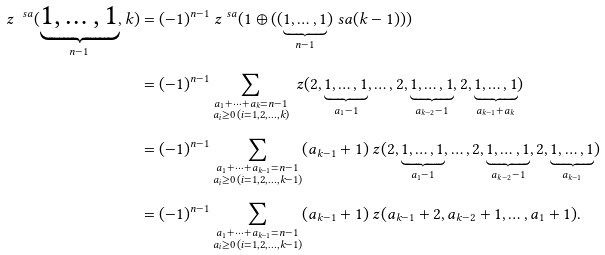<formula> <loc_0><loc_0><loc_500><loc_500>\ z ^ { \ s a } ( \underbrace { 1 , \dots , 1 } _ { n - 1 } , k ) & = ( - 1 ) ^ { n - 1 } \ z ^ { \ s a } ( 1 \oplus ( ( \underbrace { 1 , \dots , 1 } _ { n - 1 } ) \ s a ( k - 1 ) ) ) \\ & = ( - 1 ) ^ { n - 1 } \sum _ { \substack { { a _ { 1 } + \cdots + a _ { k } = n - 1 } \\ a _ { i } \geq 0 \, ( i = 1 , 2 , \dots , k ) } } \ z ( 2 , \underbrace { 1 , \dots , 1 } _ { a _ { 1 } - 1 } , \dots , 2 , \underbrace { 1 , \dots , 1 } _ { a _ { k - 2 } - 1 } , 2 , \underbrace { 1 , \dots , 1 } _ { a _ { k - 1 } + a _ { k } } ) \\ & = ( - 1 ) ^ { n - 1 } \sum _ { \substack { { a _ { 1 } + \cdots + a _ { k - 1 } = n - 1 } \\ a _ { i } \geq 0 \, ( i = 1 , 2 , \dots , k - 1 ) } } ( a _ { k - 1 } + 1 ) \ z ( 2 , \underbrace { 1 , \dots , 1 } _ { a _ { 1 } - 1 } , \dots , 2 , \underbrace { 1 , \dots , 1 } _ { a _ { k - 2 } - 1 } , 2 , \underbrace { 1 , \dots , 1 } _ { a _ { k - 1 } } ) \\ & = ( - 1 ) ^ { n - 1 } \sum _ { \substack { { a _ { 1 } + \cdots + a _ { k - 1 } = n - 1 } \\ a _ { i } \geq 0 \, ( i = 1 , 2 , \dots , k - 1 ) } } ( a _ { k - 1 } + 1 ) \ z ( a _ { k - 1 } + 2 , a _ { k - 2 } + 1 , \dots , a _ { 1 } + 1 ) .</formula> 